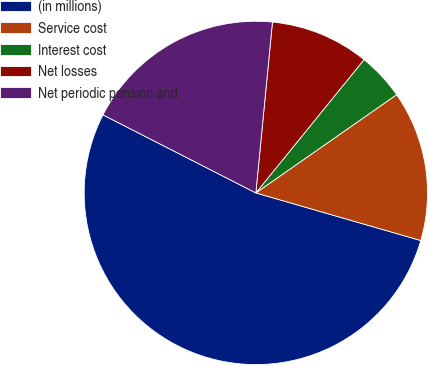Convert chart to OTSL. <chart><loc_0><loc_0><loc_500><loc_500><pie_chart><fcel>(in millions)<fcel>Service cost<fcel>Interest cost<fcel>Net losses<fcel>Net periodic pension and<nl><fcel>53.04%<fcel>14.17%<fcel>4.45%<fcel>9.31%<fcel>19.03%<nl></chart> 